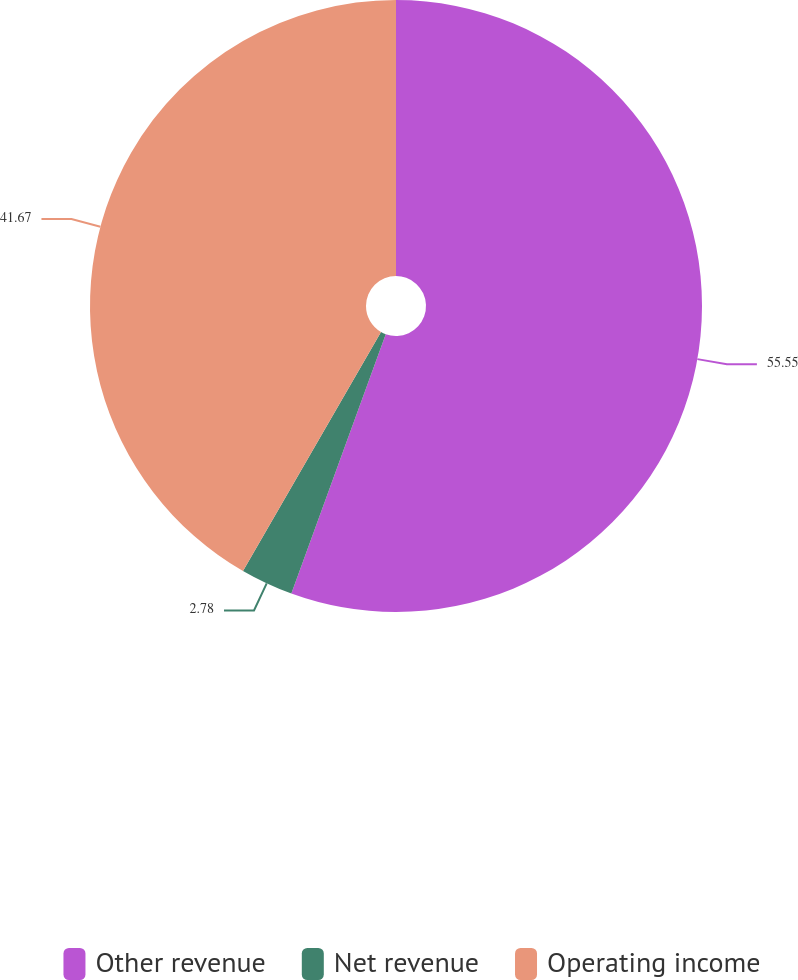Convert chart. <chart><loc_0><loc_0><loc_500><loc_500><pie_chart><fcel>Other revenue<fcel>Net revenue<fcel>Operating income<nl><fcel>55.56%<fcel>2.78%<fcel>41.67%<nl></chart> 